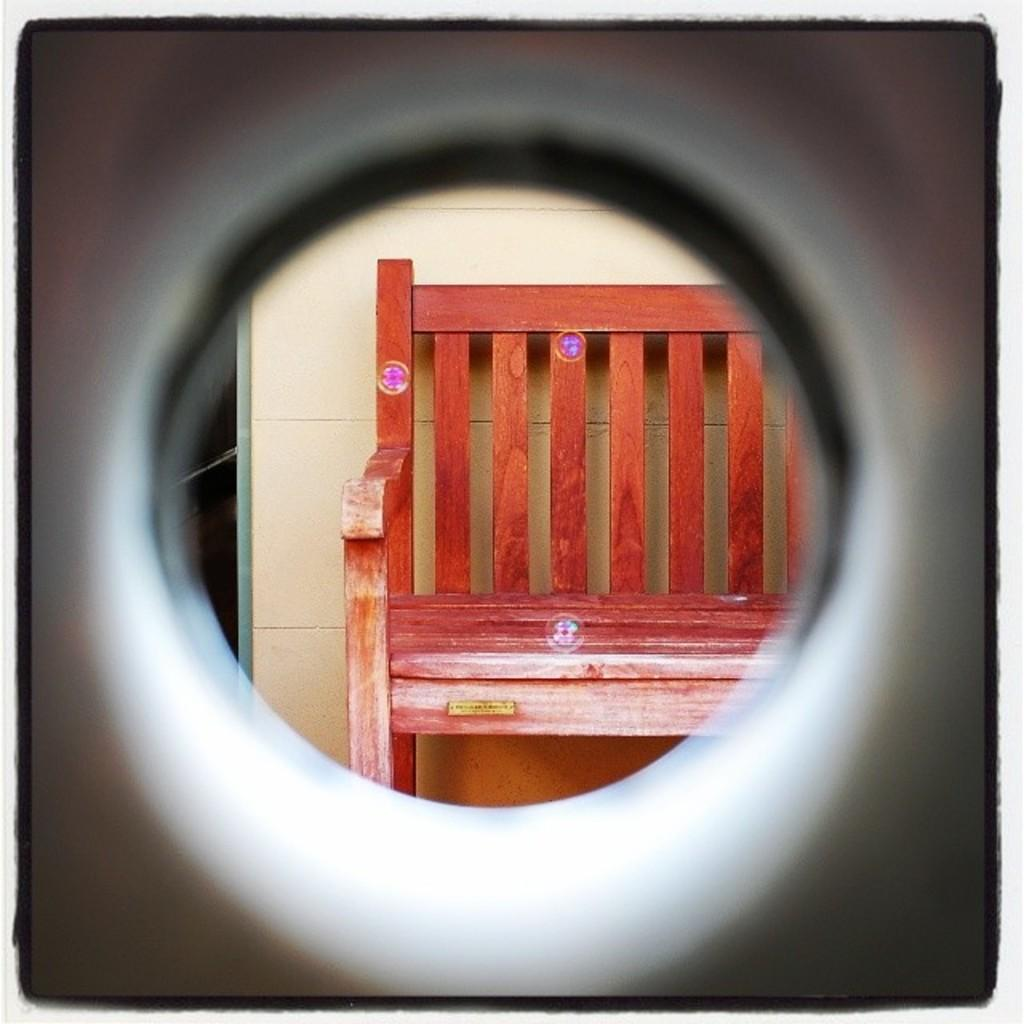What is the main feature of the image? There is a hole in the image. What can be seen through the hole? A bench is visible through the hole. Where is the bench located in relation to other objects? The bench is near a wall. How many cows are grazing near the bench in the image? There are no cows present in the image. What type of question is being asked about the image? The question being asked is about the number of cows near the bench, which is not relevant to the image as there are no cows present. 